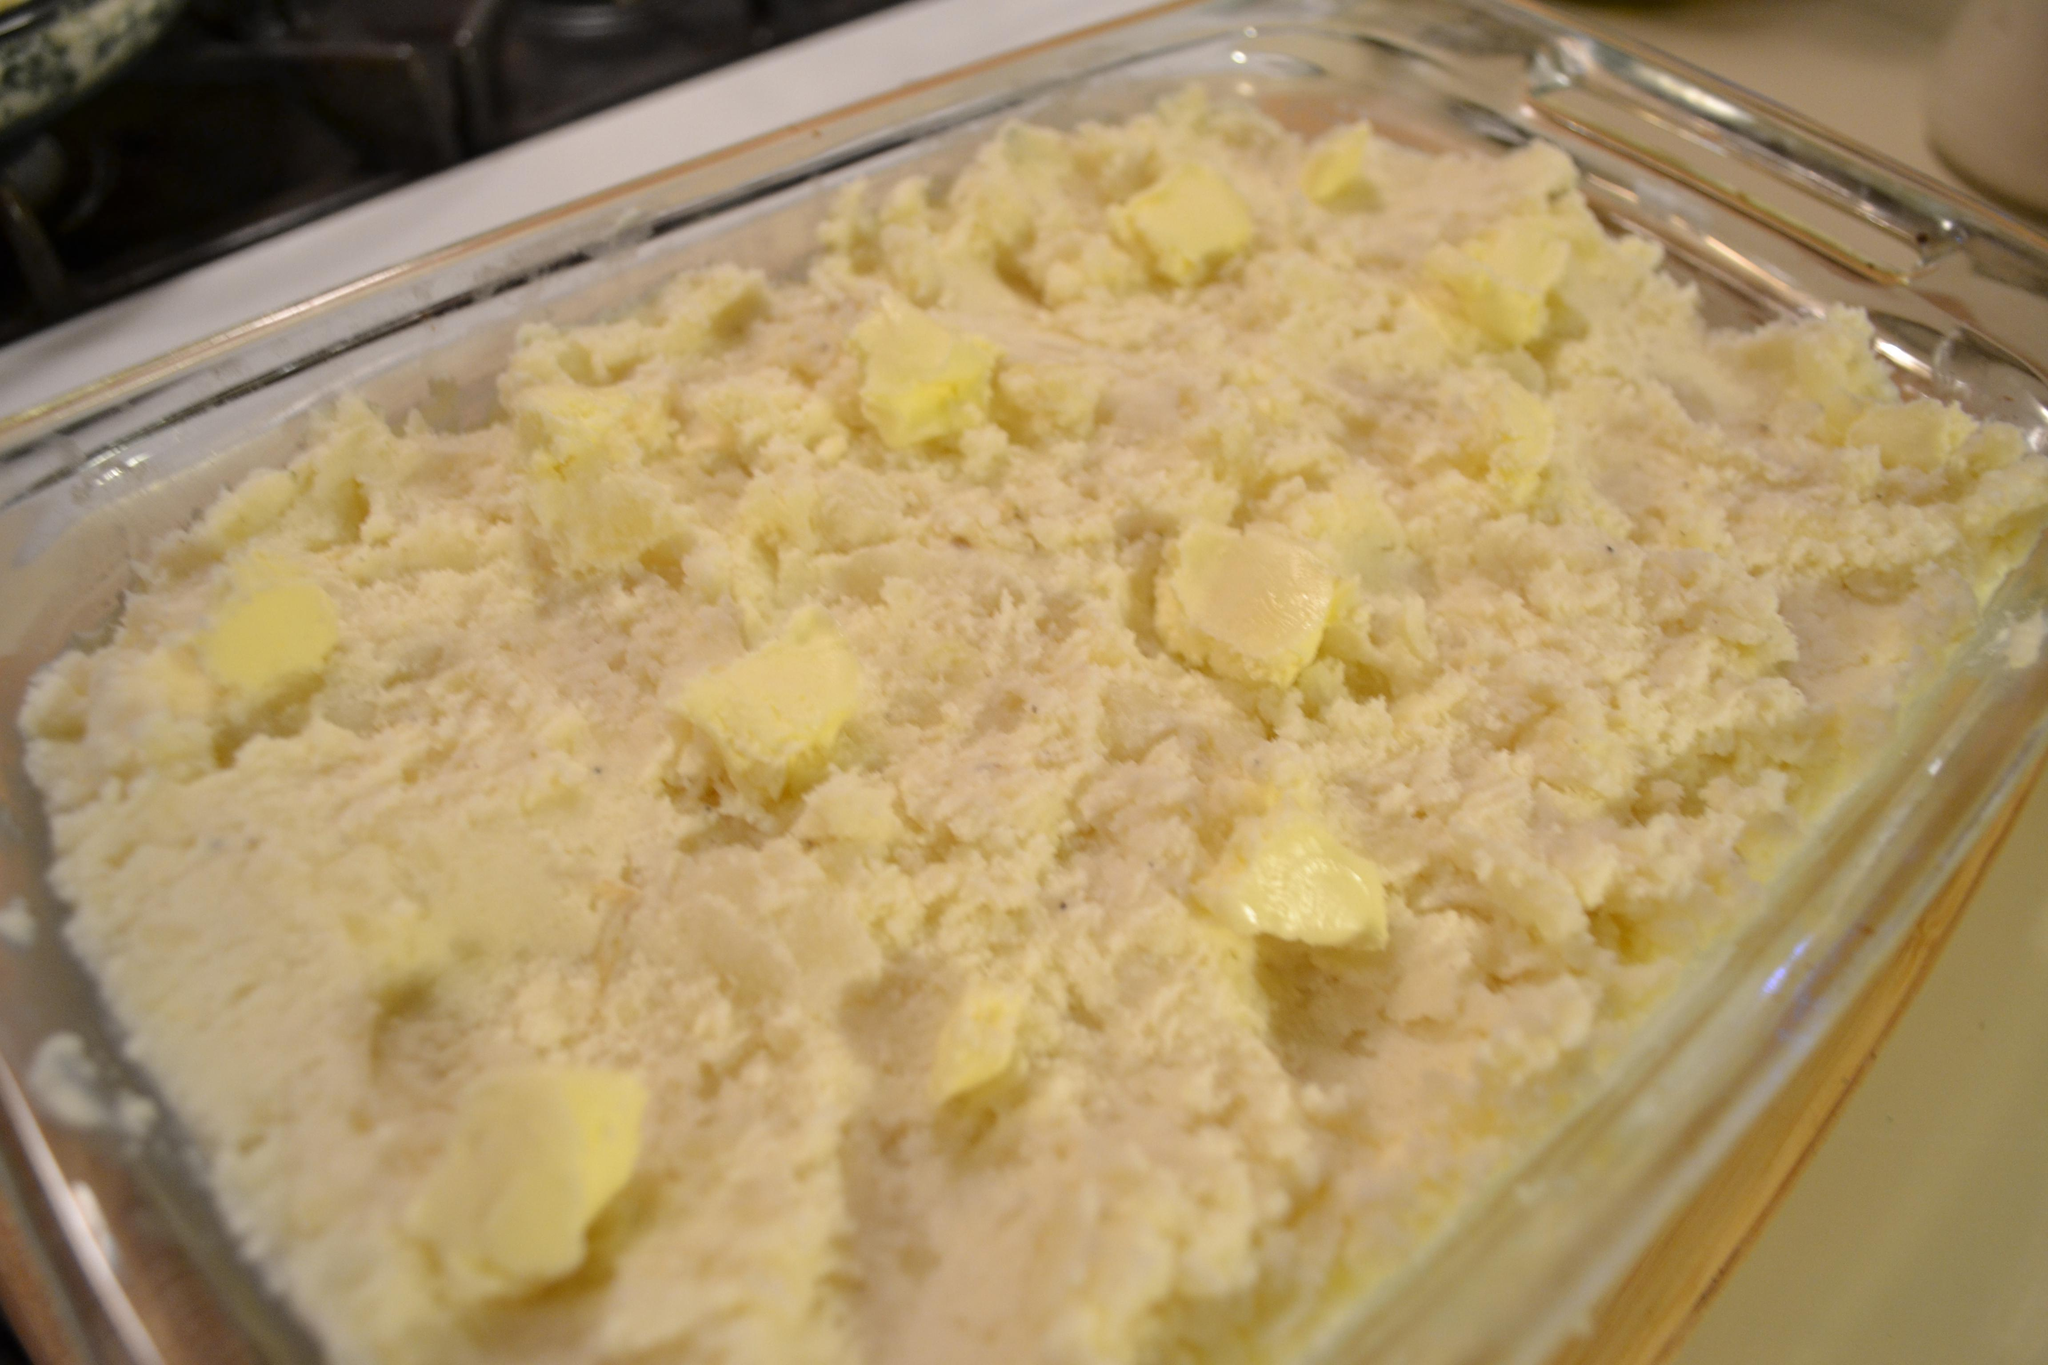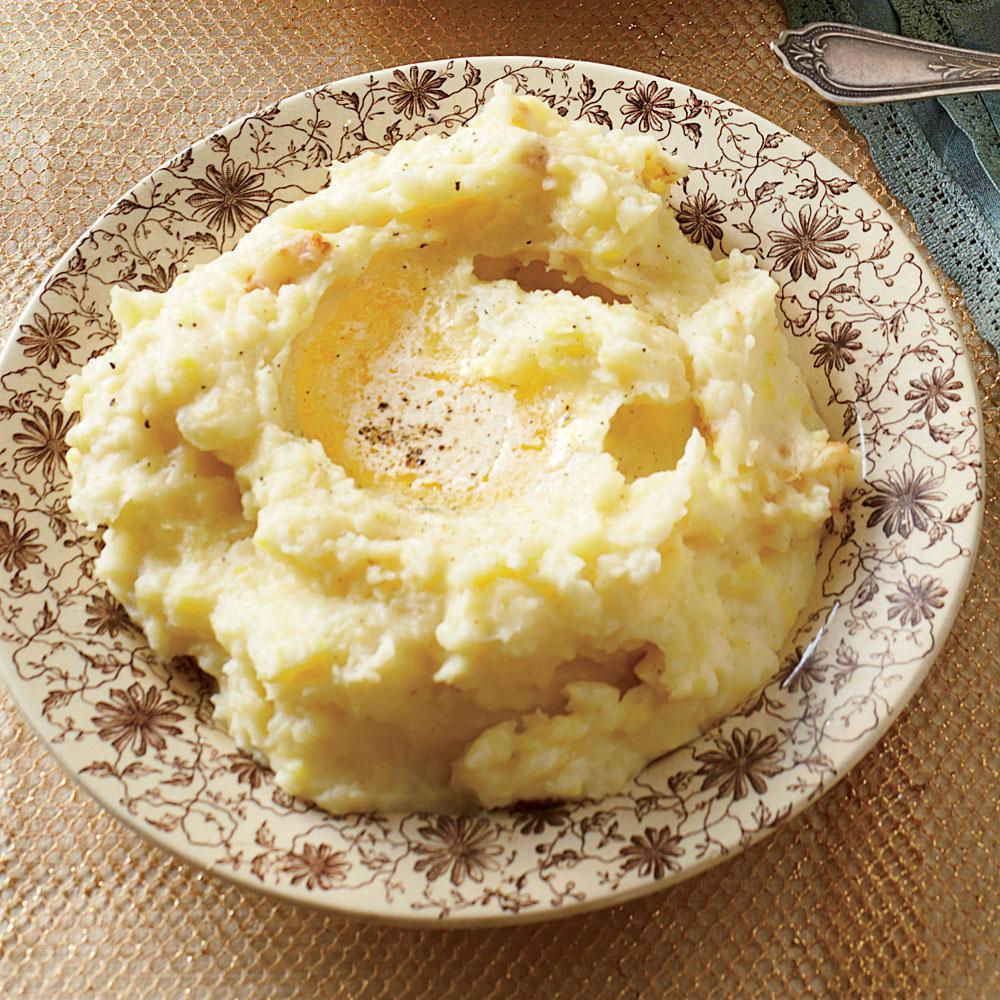The first image is the image on the left, the second image is the image on the right. Evaluate the accuracy of this statement regarding the images: "At least one serving of mashed potato is presented in clear, round glass bowl.". Is it true? Answer yes or no. No. The first image is the image on the left, the second image is the image on the right. Evaluate the accuracy of this statement regarding the images: "There is an eating utensil in a bowl of mashed potatoes.". Is it true? Answer yes or no. No. 